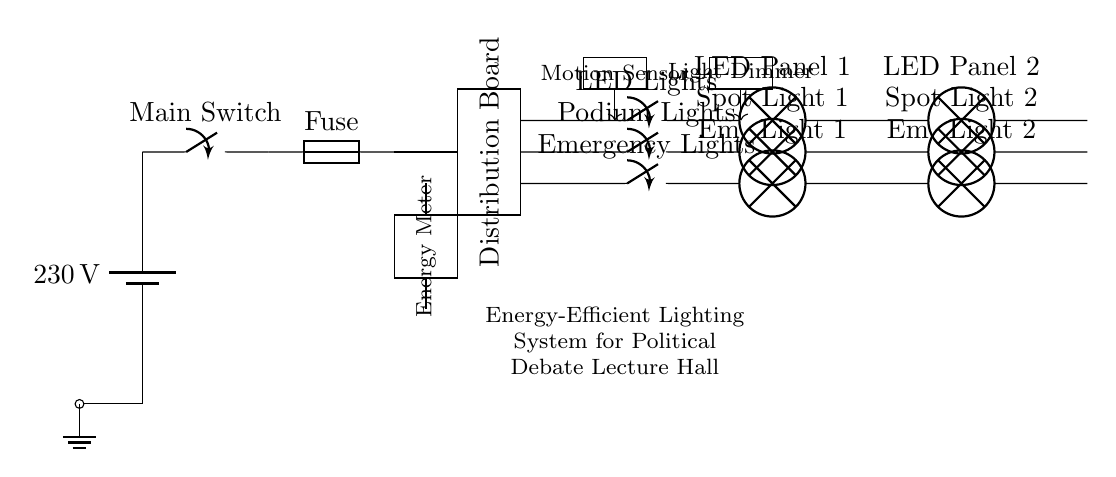What is the main voltage of this circuit? The main voltage is 230 volts, as indicated by the battery component in the circuit.
Answer: 230 volts What type of lighting is used in this system? The circuit diagram displays LED lights and spotlights, as shown by the labels on the relevant components.
Answer: LED lights and spotlights How many LED panels are connected in the circuit? There are two LED panels connected, as noted by the labels on the lamp components in the circuit path.
Answer: Two What component controls the brightness of the lights? The component that controls the brightness is the light dimmer, which is specifically marked in the circuit diagram.
Answer: Light dimmer What safety feature is present in the circuit? The safety feature present is the fuse, which helps protect the circuit from overloads or faults.
Answer: Fuse How does the circuit determine occupancy in the lecture hall? The circuit uses a motion sensor to detect occupancy, which is indicated by the labeled rectangle in the diagram.
Answer: Motion sensor What is the function of the energy meter in this circuit? The energy meter measures the electricity consumption in the circuit, as indicated by its labeling in the diagram.
Answer: Measures electricity consumption 